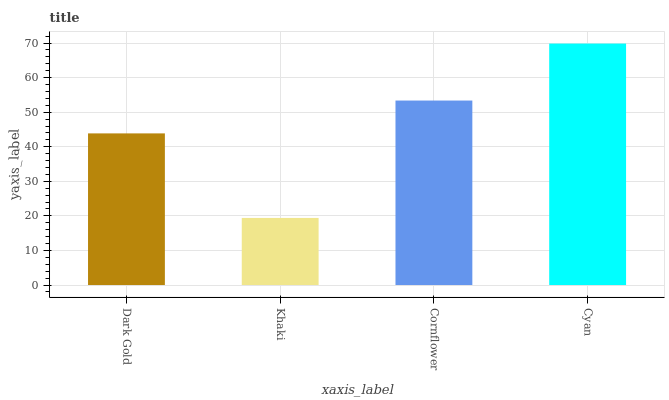Is Cornflower the minimum?
Answer yes or no. No. Is Cornflower the maximum?
Answer yes or no. No. Is Cornflower greater than Khaki?
Answer yes or no. Yes. Is Khaki less than Cornflower?
Answer yes or no. Yes. Is Khaki greater than Cornflower?
Answer yes or no. No. Is Cornflower less than Khaki?
Answer yes or no. No. Is Cornflower the high median?
Answer yes or no. Yes. Is Dark Gold the low median?
Answer yes or no. Yes. Is Dark Gold the high median?
Answer yes or no. No. Is Khaki the low median?
Answer yes or no. No. 